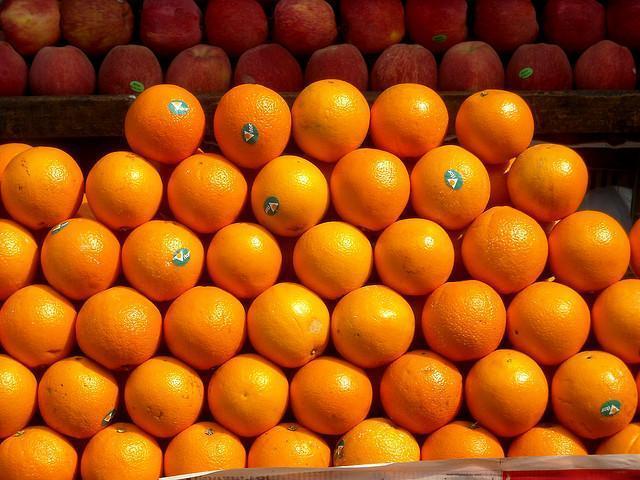How many oranges are in the photo?
Give a very brief answer. 2. How many apples are there?
Give a very brief answer. 13. How many people are in the water?
Give a very brief answer. 0. 